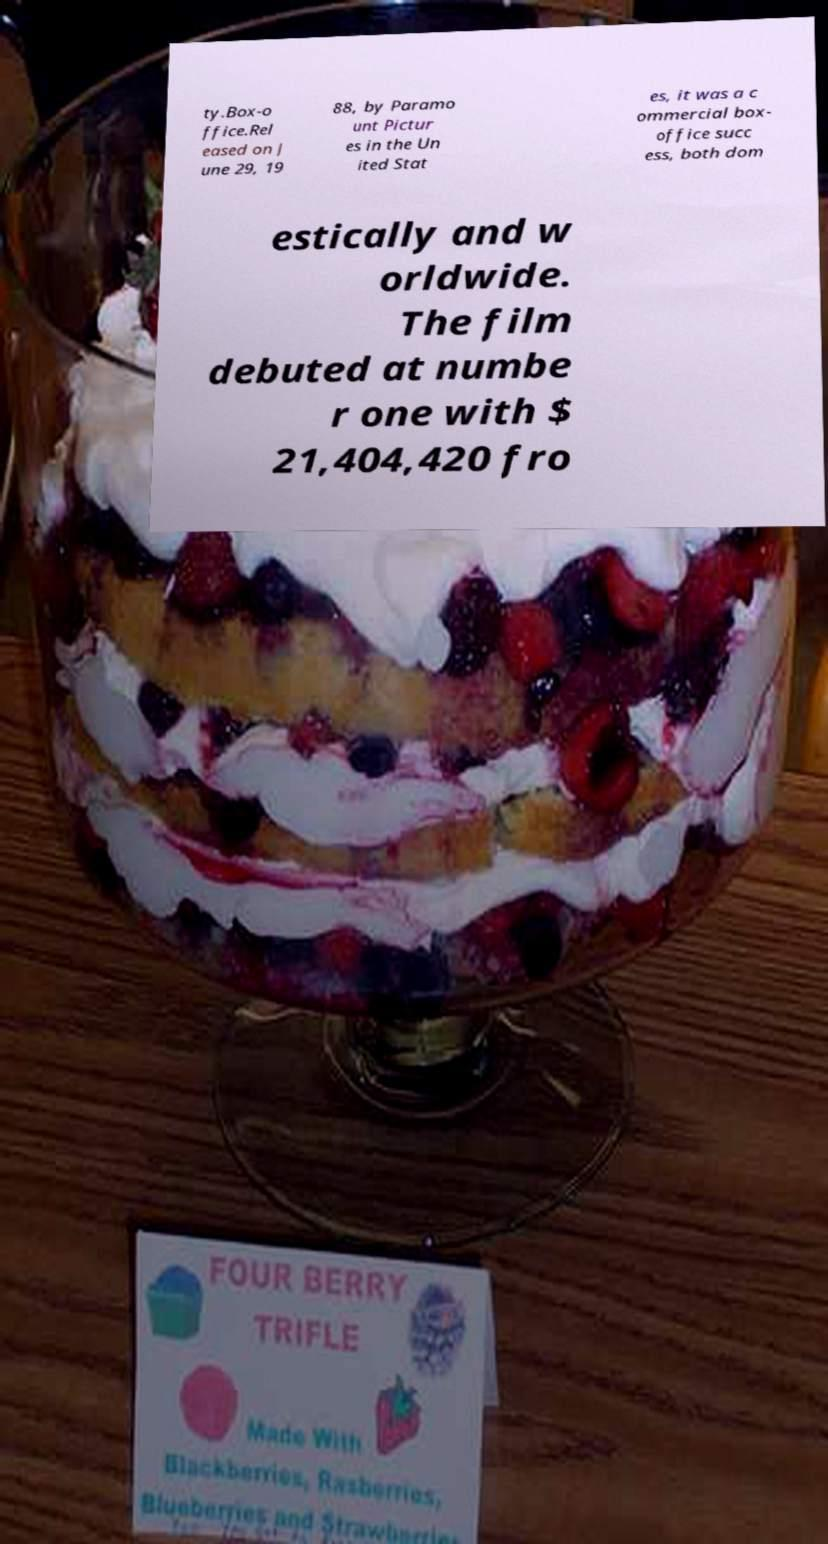Please identify and transcribe the text found in this image. ty.Box-o ffice.Rel eased on J une 29, 19 88, by Paramo unt Pictur es in the Un ited Stat es, it was a c ommercial box- office succ ess, both dom estically and w orldwide. The film debuted at numbe r one with $ 21,404,420 fro 